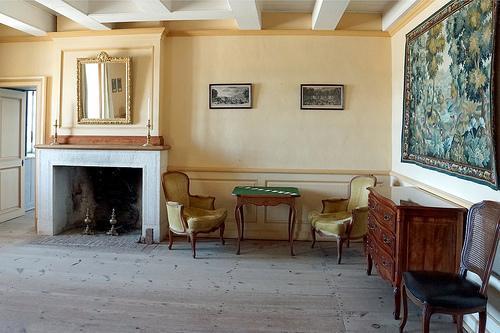How many chairs are in this photo?
Give a very brief answer. 3. 